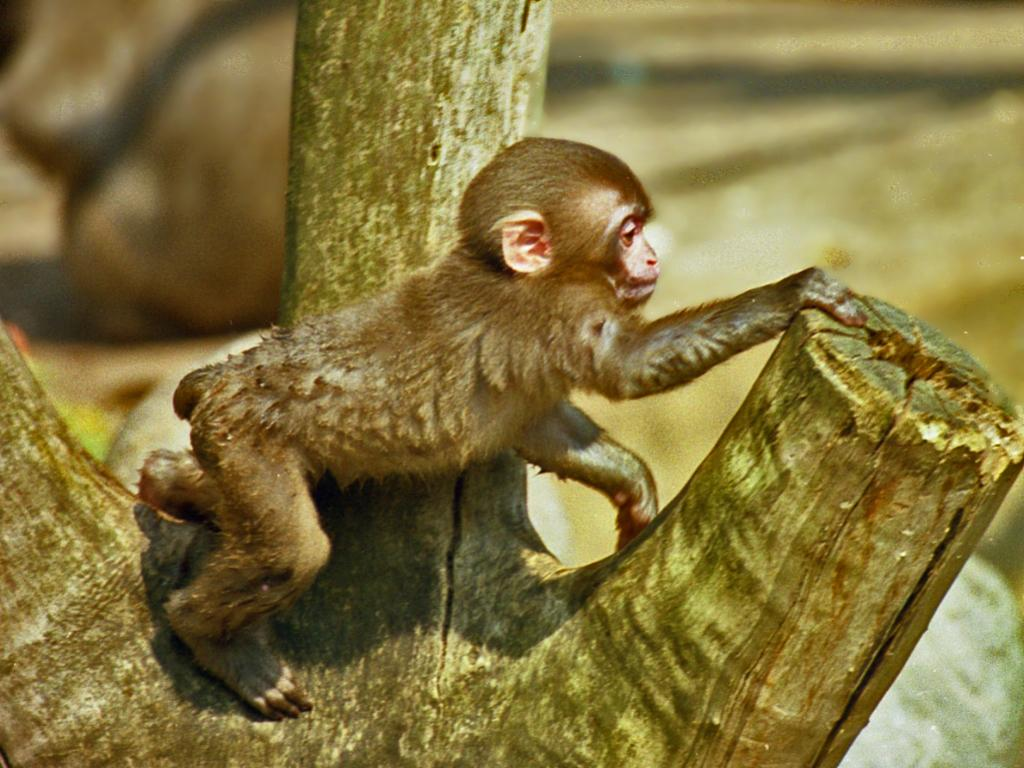What animal is present in the image? There is a monkey in the image. Where is the monkey located? The monkey is on a trunk. Can you describe the background of the image? The background of the image is blurred. What type of plough is being used by the monkey in the image? There is no plough present in the image; it features a monkey on a trunk. How does the apple tree look like in the image? There is no apple tree present in the image. 